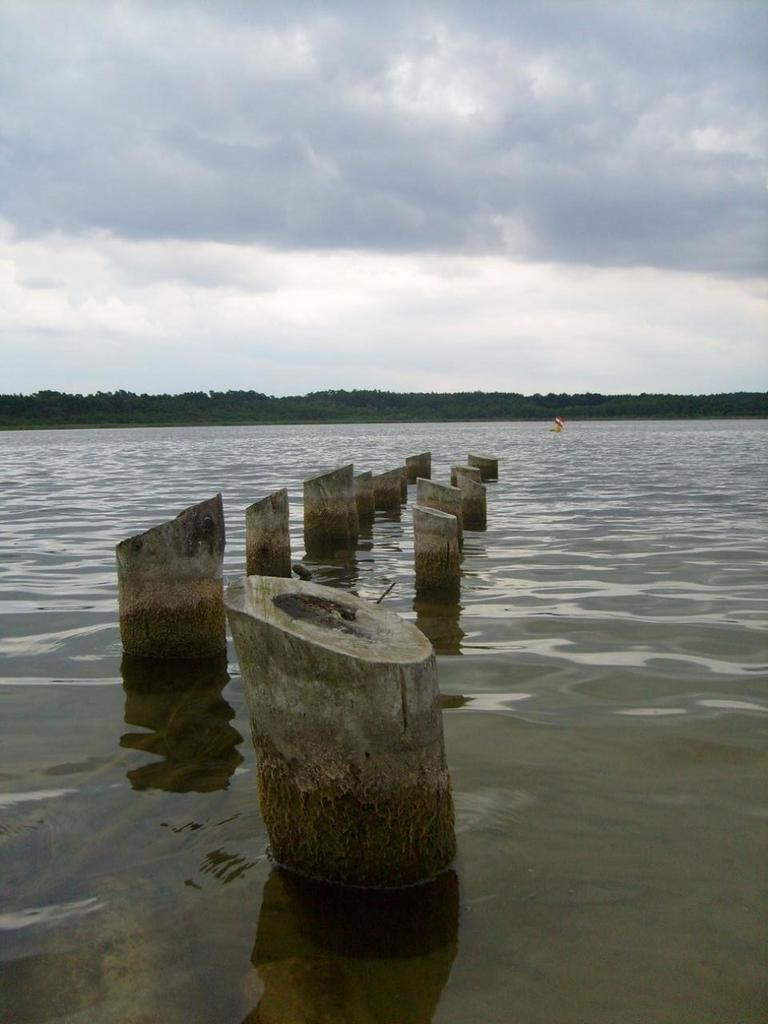What is the main subject in the center of the image? There are wooden logs in the center of the image. What can be seen in the background of the image? There is water and trees visible in the background of the image. How would you describe the sky in the image? The sky is cloudy in the image. Can you see any toes on the wooden logs in the image? There are no toes present in the image; it features wooden logs and a cloudy sky. What type of pan is being used to cook the logs in the image? There is no pan or cooking activity present in the image. 